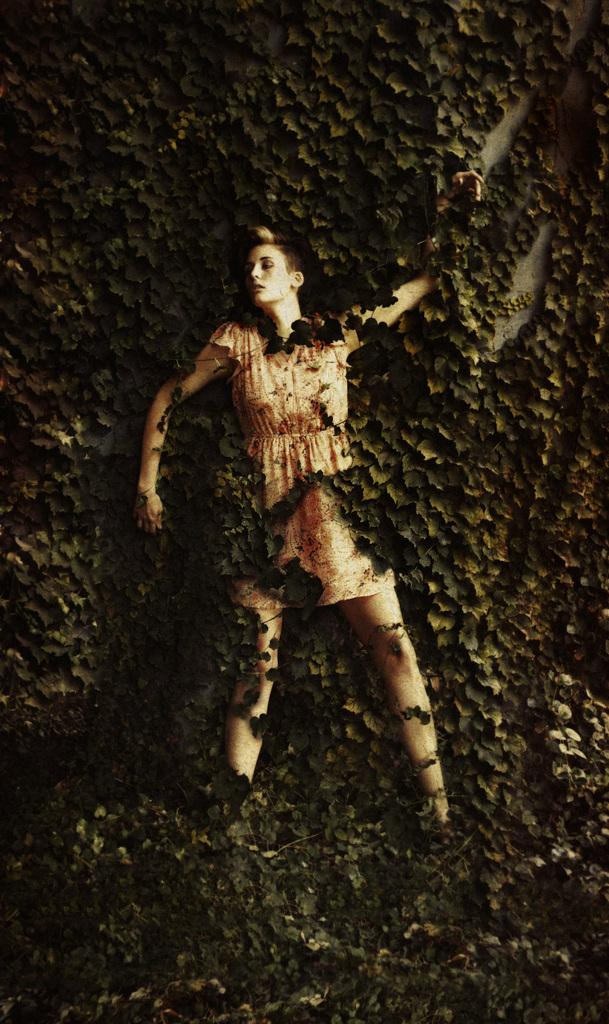Who is the main subject in the image? There is a woman in the image. What is the woman wearing? The woman is wearing a frock. What is covering some parts of the woman's body? Some parts of the woman are covered with leaves. What can be seen in the background of the image? The background of the image is fully covered with trees. What type of peace symbol can be seen in the image? There is no peace symbol present in the image. Is the woman standing on a slope in the image? The image does not provide information about the slope or terrain, so it cannot be determined from the image. 